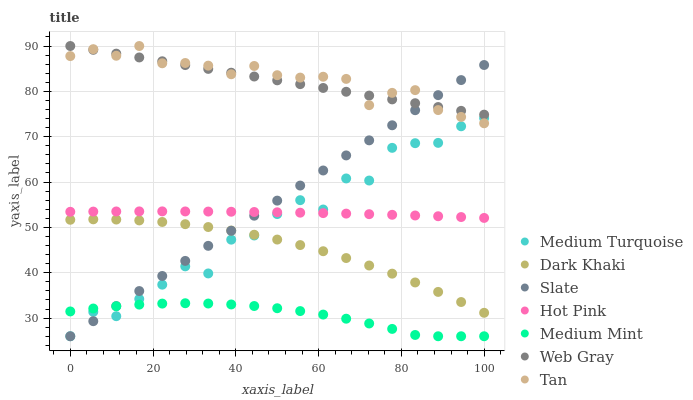Does Medium Mint have the minimum area under the curve?
Answer yes or no. Yes. Does Tan have the maximum area under the curve?
Answer yes or no. Yes. Does Web Gray have the minimum area under the curve?
Answer yes or no. No. Does Web Gray have the maximum area under the curve?
Answer yes or no. No. Is Web Gray the smoothest?
Answer yes or no. Yes. Is Medium Turquoise the roughest?
Answer yes or no. Yes. Is Slate the smoothest?
Answer yes or no. No. Is Slate the roughest?
Answer yes or no. No. Does Medium Mint have the lowest value?
Answer yes or no. Yes. Does Web Gray have the lowest value?
Answer yes or no. No. Does Tan have the highest value?
Answer yes or no. Yes. Does Slate have the highest value?
Answer yes or no. No. Is Medium Mint less than Hot Pink?
Answer yes or no. Yes. Is Tan greater than Hot Pink?
Answer yes or no. Yes. Does Dark Khaki intersect Medium Turquoise?
Answer yes or no. Yes. Is Dark Khaki less than Medium Turquoise?
Answer yes or no. No. Is Dark Khaki greater than Medium Turquoise?
Answer yes or no. No. Does Medium Mint intersect Hot Pink?
Answer yes or no. No. 